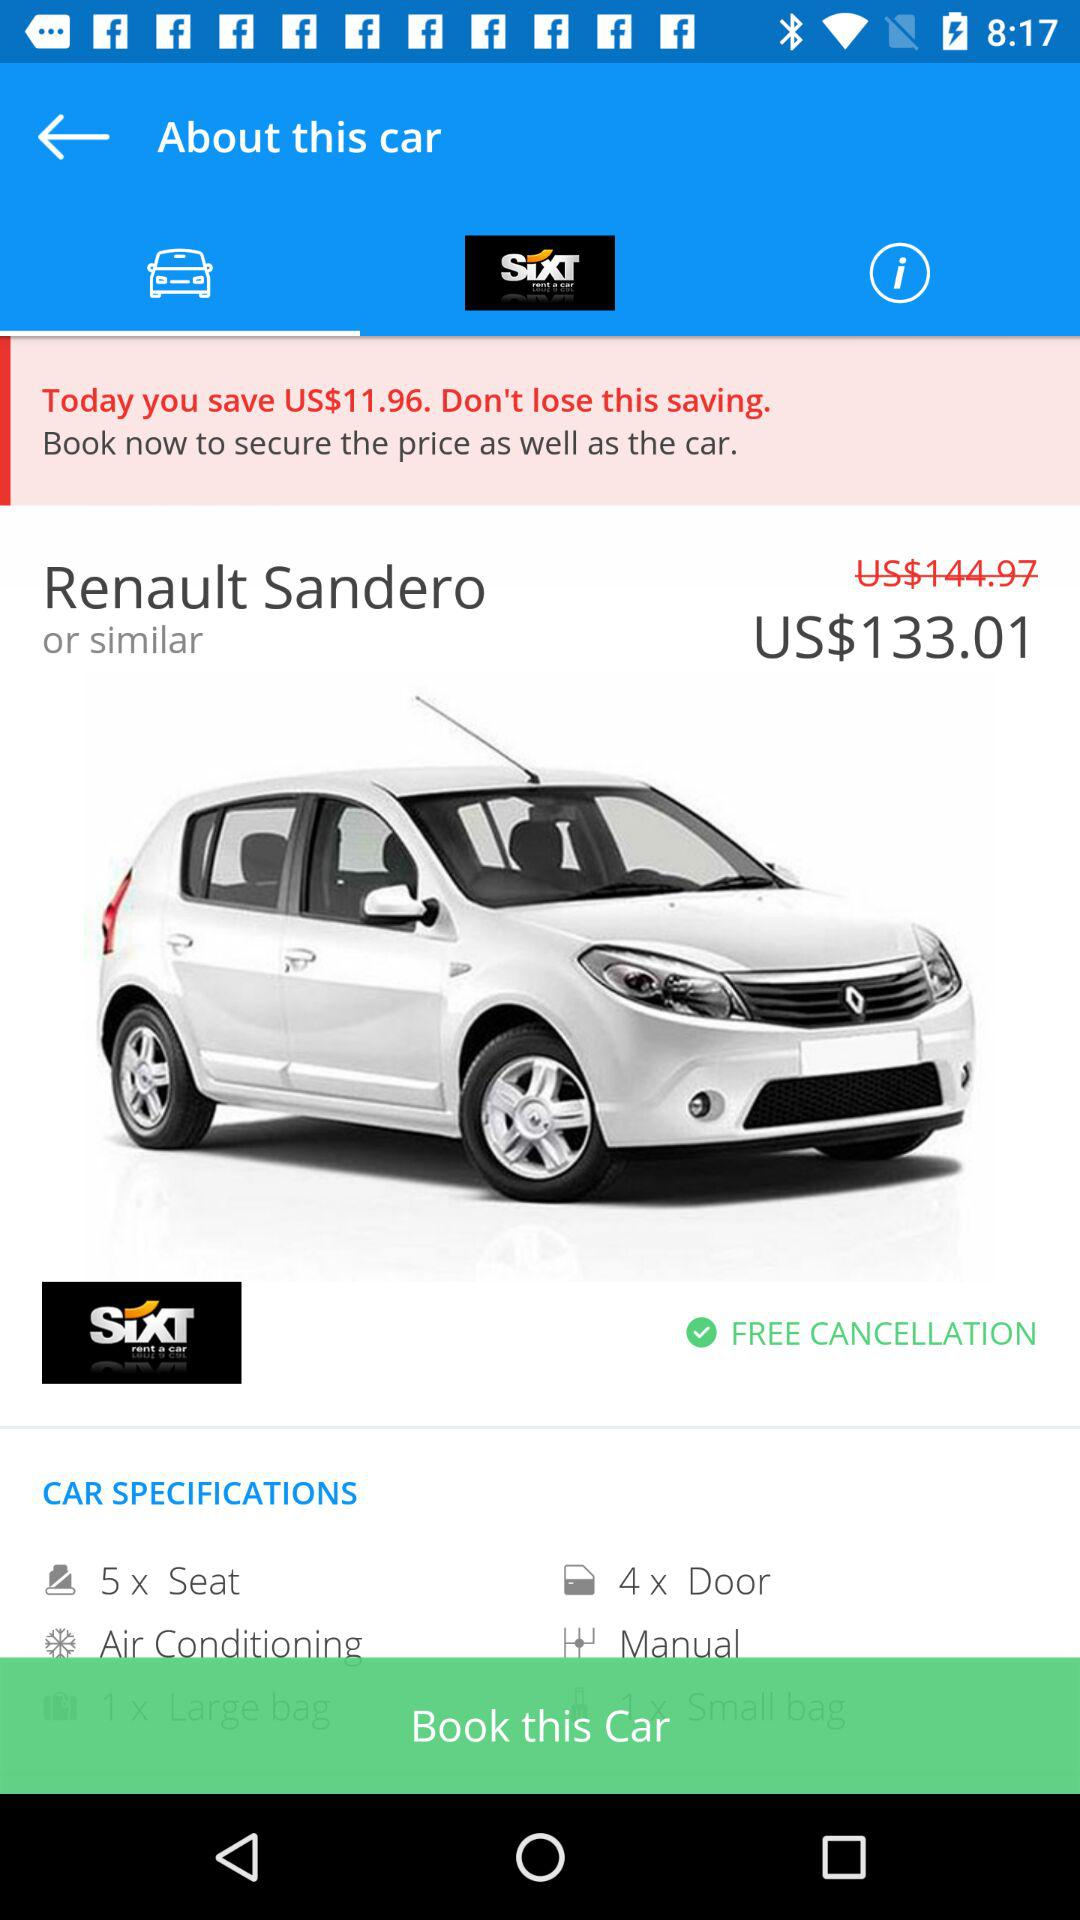How many doors does the car have?
Answer the question using a single word or phrase. 4 